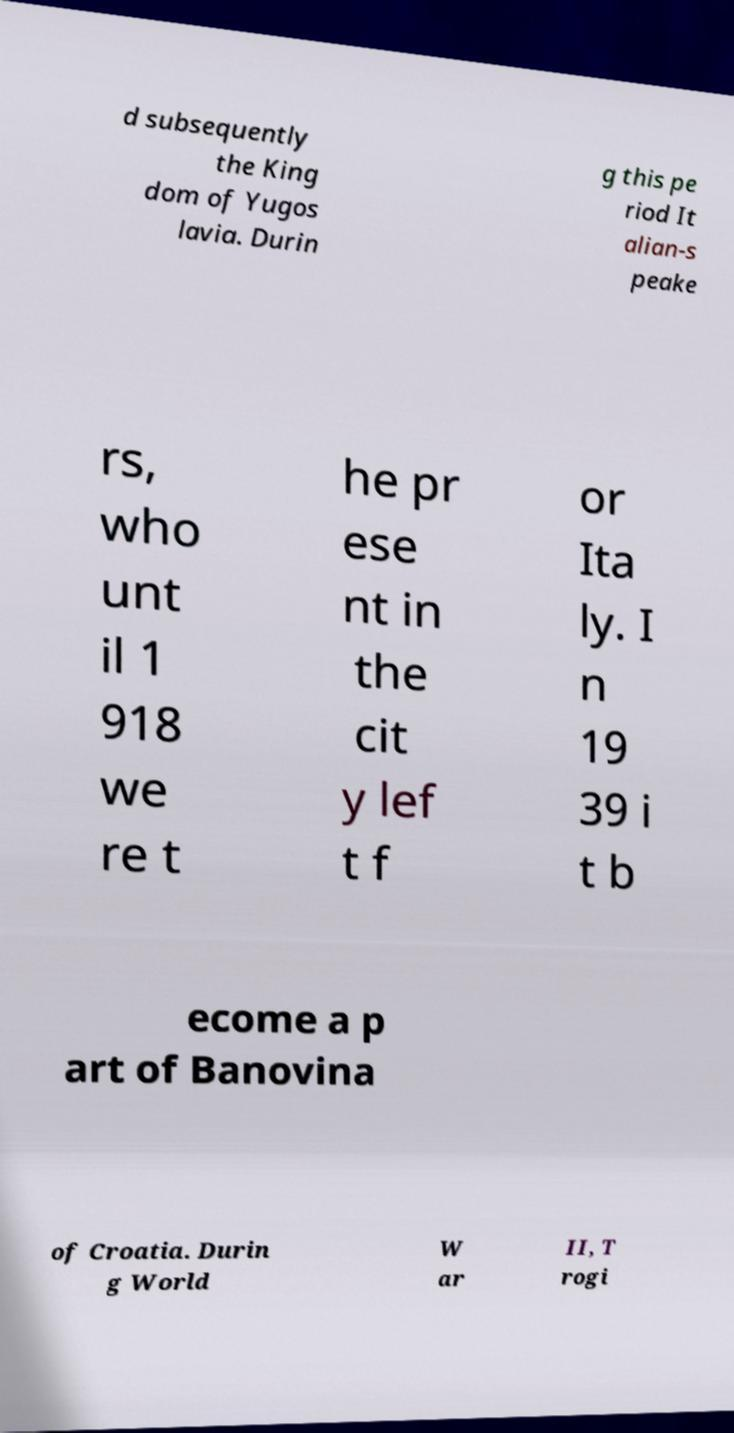Can you read and provide the text displayed in the image?This photo seems to have some interesting text. Can you extract and type it out for me? d subsequently the King dom of Yugos lavia. Durin g this pe riod It alian-s peake rs, who unt il 1 918 we re t he pr ese nt in the cit y lef t f or Ita ly. I n 19 39 i t b ecome a p art of Banovina of Croatia. Durin g World W ar II, T rogi 